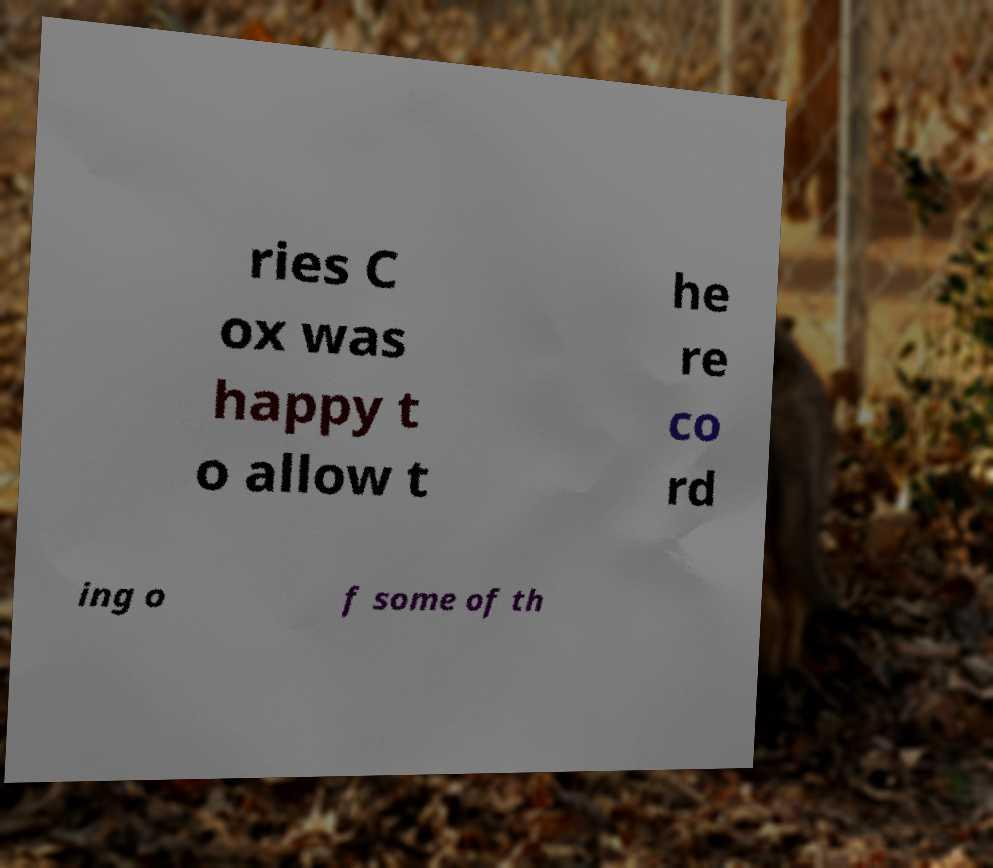Please read and relay the text visible in this image. What does it say? ries C ox was happy t o allow t he re co rd ing o f some of th 